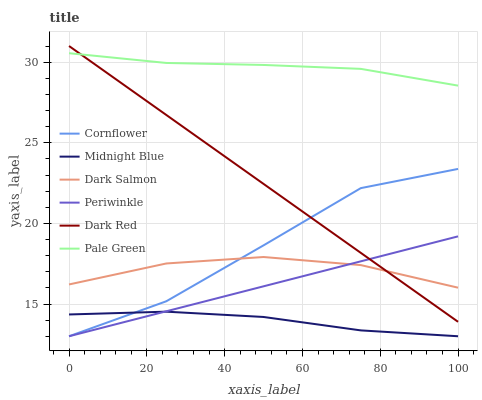Does Midnight Blue have the minimum area under the curve?
Answer yes or no. Yes. Does Pale Green have the maximum area under the curve?
Answer yes or no. Yes. Does Dark Red have the minimum area under the curve?
Answer yes or no. No. Does Dark Red have the maximum area under the curve?
Answer yes or no. No. Is Dark Red the smoothest?
Answer yes or no. Yes. Is Cornflower the roughest?
Answer yes or no. Yes. Is Midnight Blue the smoothest?
Answer yes or no. No. Is Midnight Blue the roughest?
Answer yes or no. No. Does Cornflower have the lowest value?
Answer yes or no. Yes. Does Dark Red have the lowest value?
Answer yes or no. No. Does Dark Red have the highest value?
Answer yes or no. Yes. Does Midnight Blue have the highest value?
Answer yes or no. No. Is Midnight Blue less than Dark Red?
Answer yes or no. Yes. Is Dark Salmon greater than Midnight Blue?
Answer yes or no. Yes. Does Dark Salmon intersect Periwinkle?
Answer yes or no. Yes. Is Dark Salmon less than Periwinkle?
Answer yes or no. No. Is Dark Salmon greater than Periwinkle?
Answer yes or no. No. Does Midnight Blue intersect Dark Red?
Answer yes or no. No. 